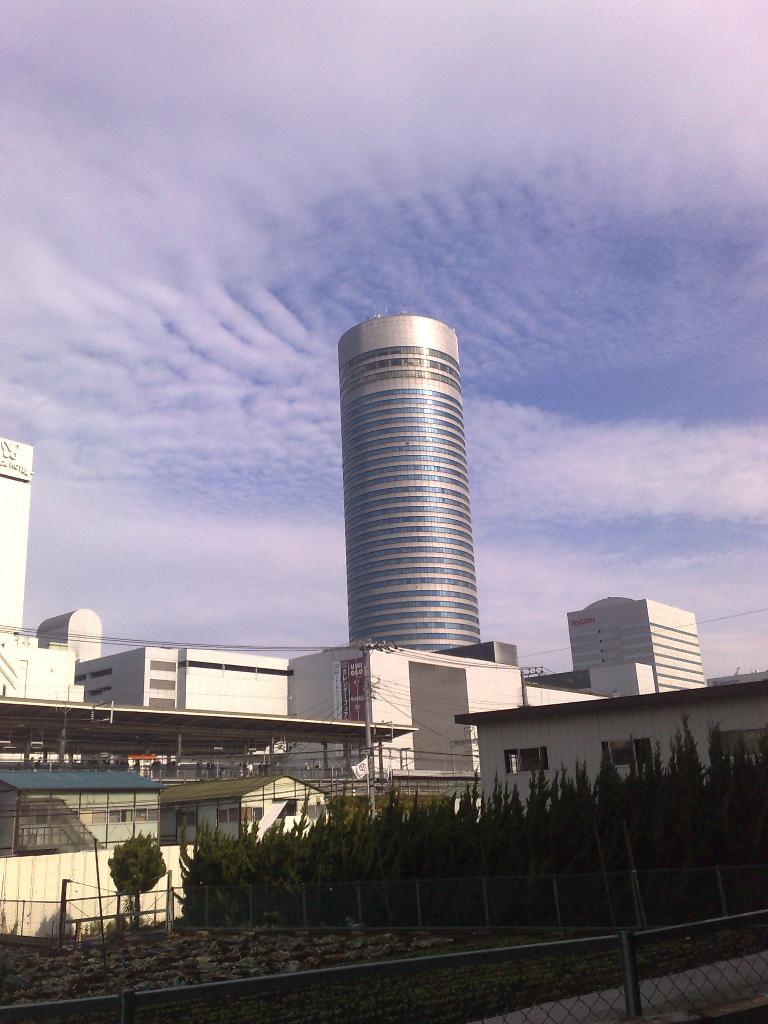What type of vegetation is at the bottom of the image? There are trees at the bottom of the image. What structures are located in the middle of the image? There are buildings in the middle of the image. What is visible at the top of the image? The sky is visible at the top of the image. What is the condition of the sky in the image? The sky appears to be cloudy. Can you tell me how many lawyers are depicted in the image? There are no lawyers present in the image. What type of needle can be seen in the image? There is no needle present in the image. 